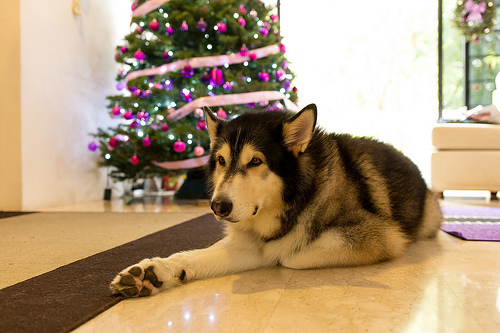<image>
Is the dog behind the tree? No. The dog is not behind the tree. From this viewpoint, the dog appears to be positioned elsewhere in the scene. Where is the dog in relation to the tree? Is it to the right of the tree? No. The dog is not to the right of the tree. The horizontal positioning shows a different relationship. Is the tree in front of the dog? No. The tree is not in front of the dog. The spatial positioning shows a different relationship between these objects. 